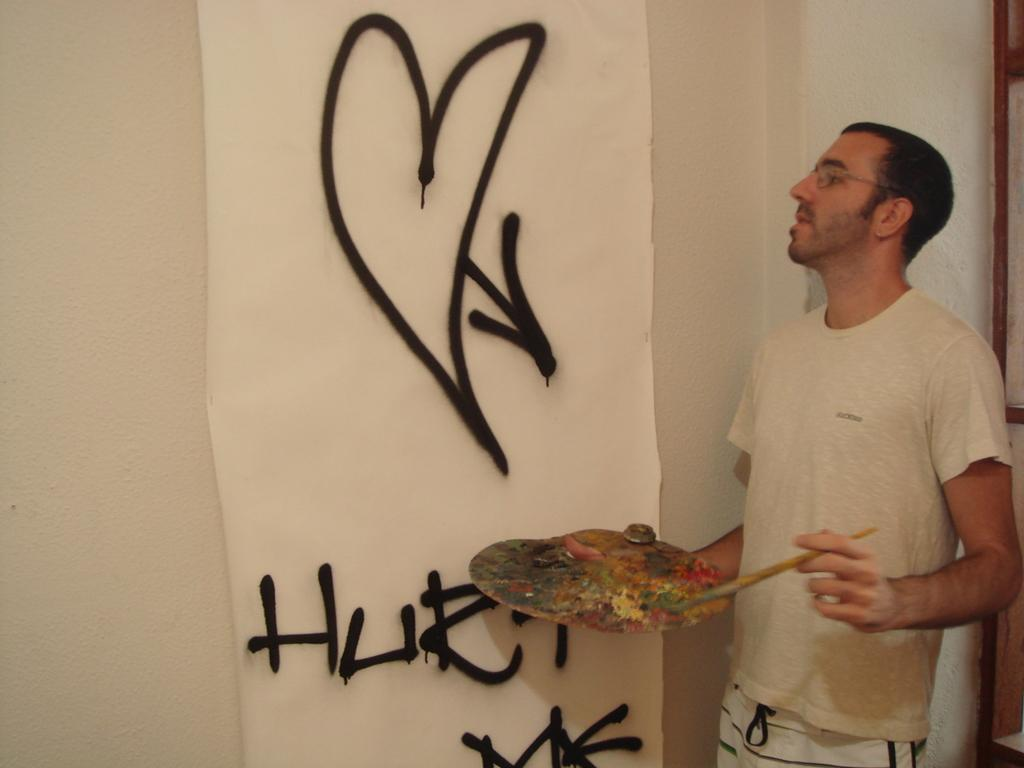What is the main subject in the front of the image? There is a man standing in the front of the image. What is the man holding in his hand? The man is holding an object in his hand. What can be seen in the center of the image? There is a banner in the center of the image. What information is provided on the banner? There is text written on the banner. What type of chin is visible on the man in the image? There is no chin visible on the man in the image; only his face and the object he is holding are shown. 